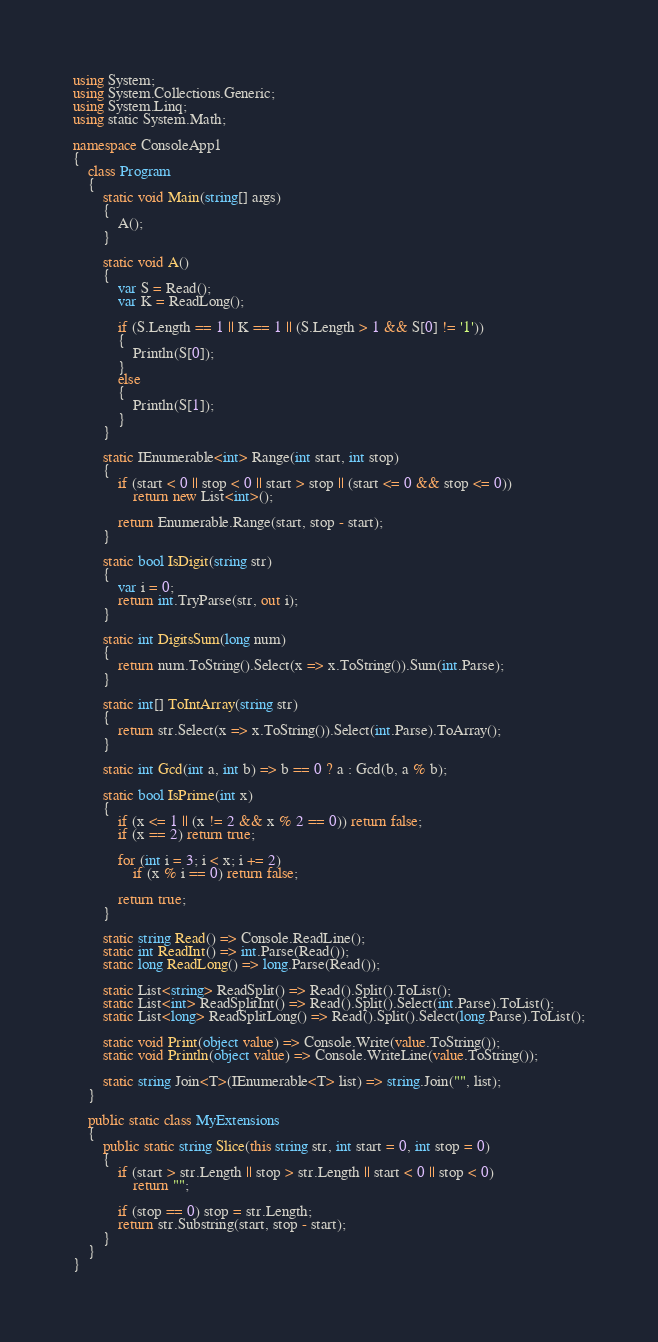<code> <loc_0><loc_0><loc_500><loc_500><_C#_>using System;
using System.Collections.Generic;
using System.Linq;
using static System.Math;

namespace ConsoleApp1
{
    class Program
    {
        static void Main(string[] args)
        {
            A();
        }

        static void A()
        {
            var S = Read();
            var K = ReadLong();

            if (S.Length == 1 || K == 1 || (S.Length > 1 && S[0] != '1'))
            {
                Println(S[0]);
            }
            else
            {
                Println(S[1]);
            }
        }

        static IEnumerable<int> Range(int start, int stop)
        {
            if (start < 0 || stop < 0 || start > stop || (start <= 0 && stop <= 0))
                return new List<int>();

            return Enumerable.Range(start, stop - start);
        }

        static bool IsDigit(string str)
        {
            var i = 0;
            return int.TryParse(str, out i);
        }

        static int DigitsSum(long num)
        {
            return num.ToString().Select(x => x.ToString()).Sum(int.Parse);
        }

        static int[] ToIntArray(string str)
        {
            return str.Select(x => x.ToString()).Select(int.Parse).ToArray();
        }

        static int Gcd(int a, int b) => b == 0 ? a : Gcd(b, a % b);

        static bool IsPrime(int x)
        {
            if (x <= 1 || (x != 2 && x % 2 == 0)) return false;
            if (x == 2) return true;

            for (int i = 3; i < x; i += 2)
                if (x % i == 0) return false;

            return true;
        }

        static string Read() => Console.ReadLine();
        static int ReadInt() => int.Parse(Read());
        static long ReadLong() => long.Parse(Read());

        static List<string> ReadSplit() => Read().Split().ToList();
        static List<int> ReadSplitInt() => Read().Split().Select(int.Parse).ToList();
        static List<long> ReadSplitLong() => Read().Split().Select(long.Parse).ToList();

        static void Print(object value) => Console.Write(value.ToString());
        static void Println(object value) => Console.WriteLine(value.ToString());

        static string Join<T>(IEnumerable<T> list) => string.Join("", list);
    }

    public static class MyExtensions
    {
        public static string Slice(this string str, int start = 0, int stop = 0)
        {
            if (start > str.Length || stop > str.Length || start < 0 || stop < 0)
                return "";

            if (stop == 0) stop = str.Length;
            return str.Substring(start, stop - start);
        }
    }
}
</code> 